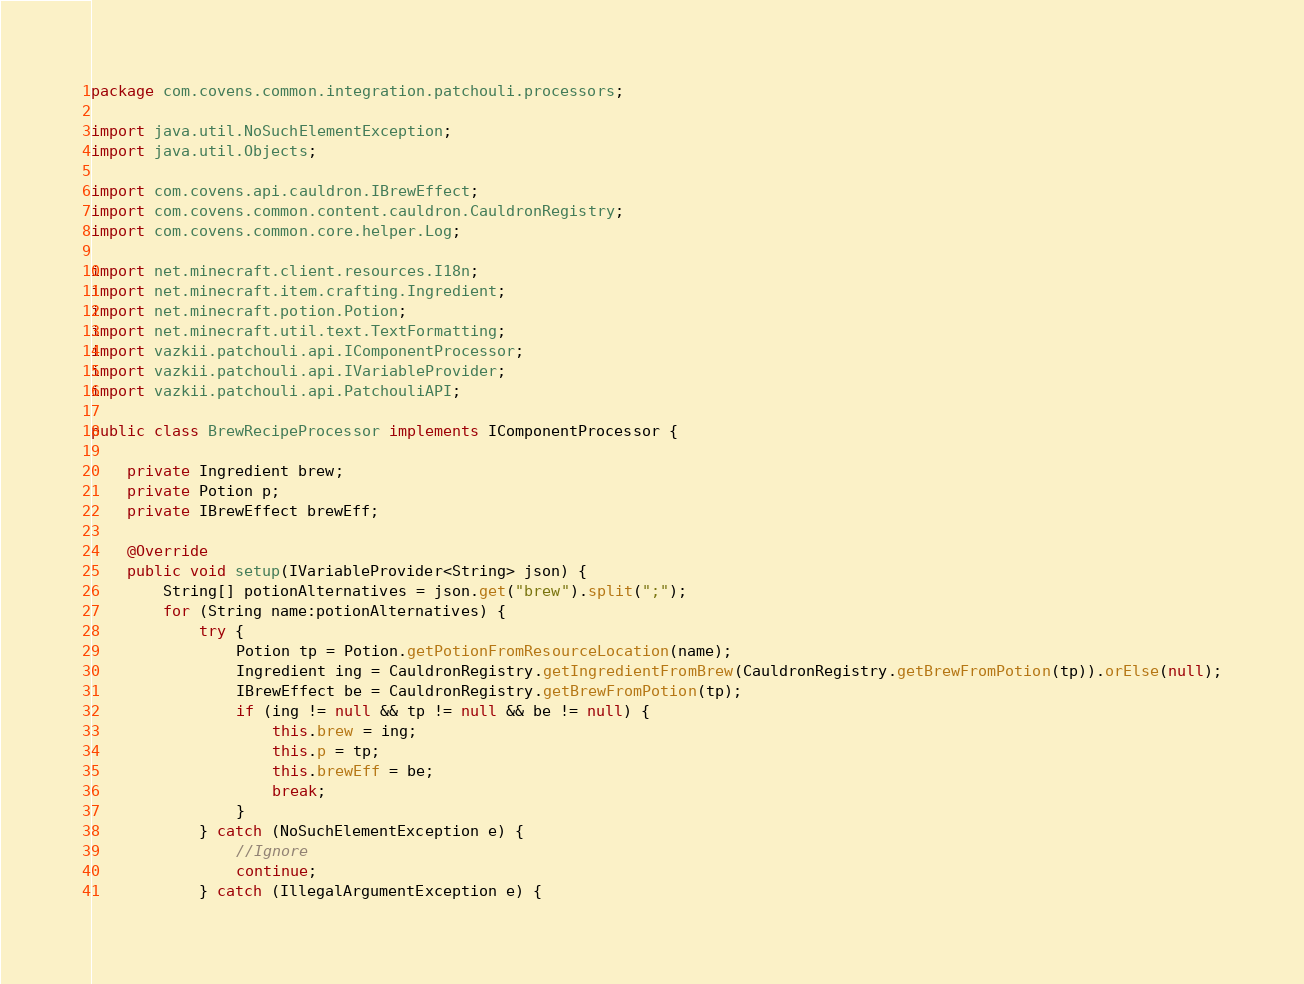<code> <loc_0><loc_0><loc_500><loc_500><_Java_>package com.covens.common.integration.patchouli.processors;

import java.util.NoSuchElementException;
import java.util.Objects;

import com.covens.api.cauldron.IBrewEffect;
import com.covens.common.content.cauldron.CauldronRegistry;
import com.covens.common.core.helper.Log;

import net.minecraft.client.resources.I18n;
import net.minecraft.item.crafting.Ingredient;
import net.minecraft.potion.Potion;
import net.minecraft.util.text.TextFormatting;
import vazkii.patchouli.api.IComponentProcessor;
import vazkii.patchouli.api.IVariableProvider;
import vazkii.patchouli.api.PatchouliAPI;

public class BrewRecipeProcessor implements IComponentProcessor {

	private Ingredient brew;
	private Potion p;
	private IBrewEffect brewEff;

	@Override
	public void setup(IVariableProvider<String> json) {
		String[] potionAlternatives = json.get("brew").split(";");
		for (String name:potionAlternatives) {
			try {
				Potion tp = Potion.getPotionFromResourceLocation(name);
				Ingredient ing = CauldronRegistry.getIngredientFromBrew(CauldronRegistry.getBrewFromPotion(tp)).orElse(null);
				IBrewEffect be = CauldronRegistry.getBrewFromPotion(tp);
				if (ing != null && tp != null && be != null) {
					this.brew = ing;
					this.p = tp;
					this.brewEff = be;
					break;
				}
			} catch (NoSuchElementException e) {
				//Ignore
				continue;
			} catch (IllegalArgumentException e) {</code> 